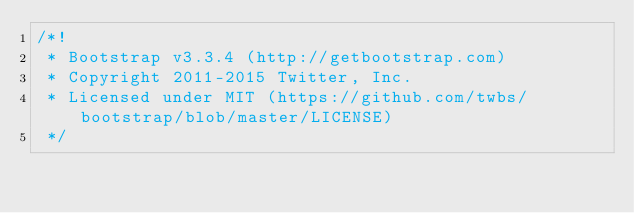<code> <loc_0><loc_0><loc_500><loc_500><_JavaScript_>/*!
 * Bootstrap v3.3.4 (http://getbootstrap.com)
 * Copyright 2011-2015 Twitter, Inc.
 * Licensed under MIT (https://github.com/twbs/bootstrap/blob/master/LICENSE)
 */</code> 